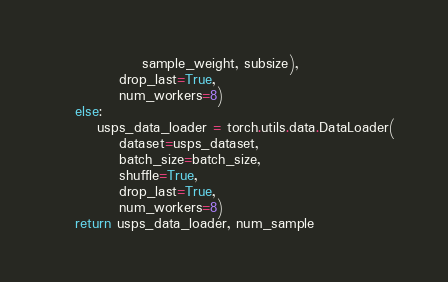Convert code to text. <code><loc_0><loc_0><loc_500><loc_500><_Python_>                sample_weight, subsize),
            drop_last=True,
            num_workers=8)
    else: 
        usps_data_loader = torch.utils.data.DataLoader(
            dataset=usps_dataset,
            batch_size=batch_size,
            shuffle=True,
            drop_last=True,
            num_workers=8)
    return usps_data_loader, num_sample
</code> 